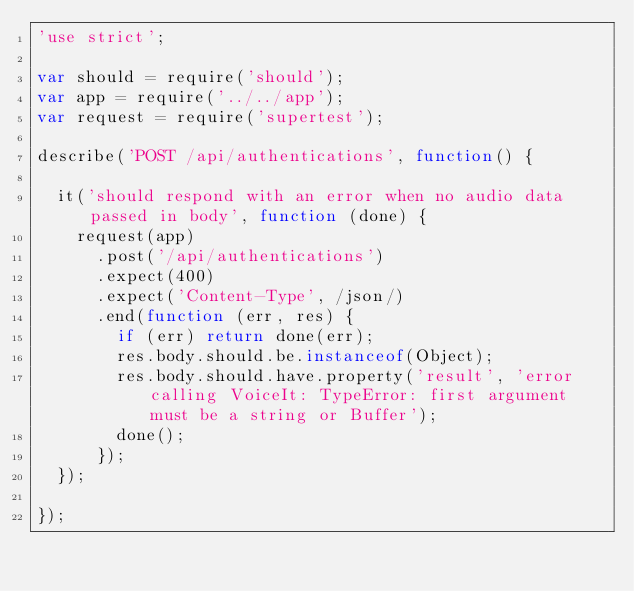<code> <loc_0><loc_0><loc_500><loc_500><_JavaScript_>'use strict';

var should = require('should');
var app = require('../../app');
var request = require('supertest');

describe('POST /api/authentications', function() {

  it('should respond with an error when no audio data passed in body', function (done) {
    request(app)
      .post('/api/authentications')
      .expect(400)
      .expect('Content-Type', /json/)
      .end(function (err, res) {
        if (err) return done(err);
        res.body.should.be.instanceof(Object);
        res.body.should.have.property('result', 'error calling VoiceIt: TypeError: first argument must be a string or Buffer');
        done();
      });
  });

});
</code> 